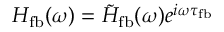Convert formula to latex. <formula><loc_0><loc_0><loc_500><loc_500>H _ { f b } ( \omega ) = \tilde { H } _ { f b } ( \omega ) e ^ { i \omega \tau _ { f b } }</formula> 